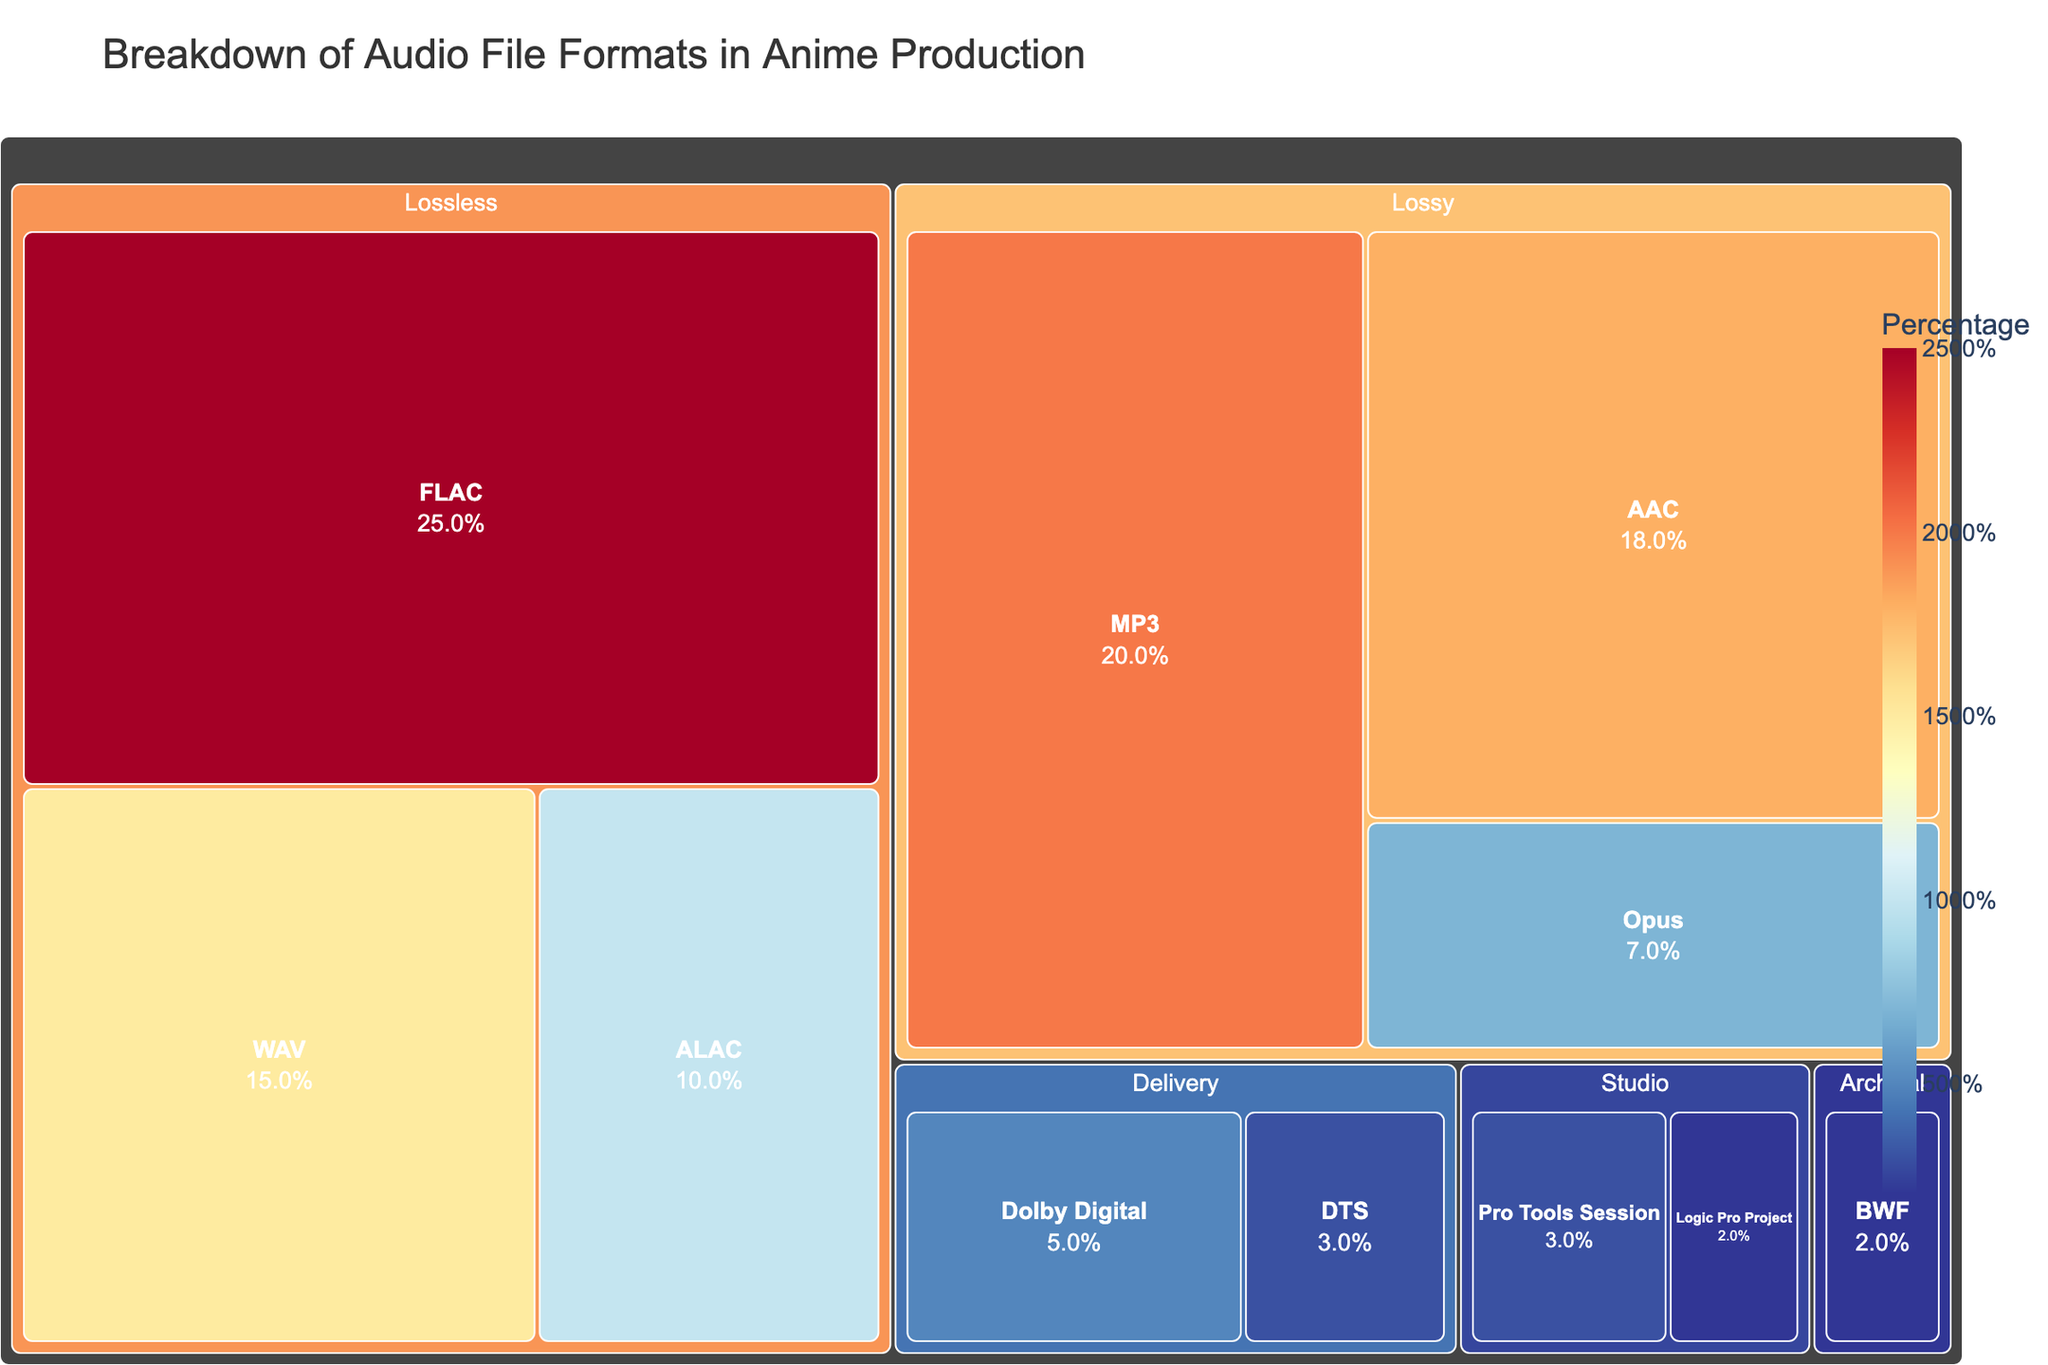What is the title of the treemap? The title is displayed at the top of the treemap, explaining the content.
Answer: Breakdown of Audio File Formats in Anime Production What file format has the highest percentage in the treemap? The format with the largest area or highest percentage value represents the highest percentage.
Answer: FLAC Which category has the least representation in the treemap? Look for the category with the smallest individual percentage values or the smallest aggregated area.
Answer: Archival How many file formats are categorized under "Lossless"? Count the number of unique formats listed under the "Lossless" category.
Answer: 3 What is the total percentage of all "Lossy" file formats combined? Sum the percentages of all formats under the "Lossy" category: 20% (MP3) + 18% (AAC) + 7% (Opus).
Answer: 45% Compare the percentages of "WAV" and "MP3". Which one is higher and by how much? Subtract the percentage of "WAV" from "MP3" to determine the difference and see which is higher. MP3: 20%, WAV: 15%, Difference: 20% - 15% = 5%.
Answer: MP3 is higher by 5% What percentage of the treemap is occupied by "Studio" category formats? Add the percentages of all formats under the "Studio" category: 3% (Pro Tools Session) + 2% (Logic Pro Project).
Answer: 5% Which format is used exclusively in both "Studio" and "Delivery" categories? Identify unique formats under both categories where the name is repeated in each category. Cross-reference with the data.
Answer: None If you add the percentages of "Dolby Digital" and "DTS," what is the total? Sum the percentages of these two formats under the "Delivery" category: 5% (Dolby Digital) + 3% (DTS).
Answer: 8% Is there a higher percentage of "AAC" or "Opus" in anime production? Compare the percentage values of "AAC" and "Opus" within their category and identify the higher value.
Answer: AAC 